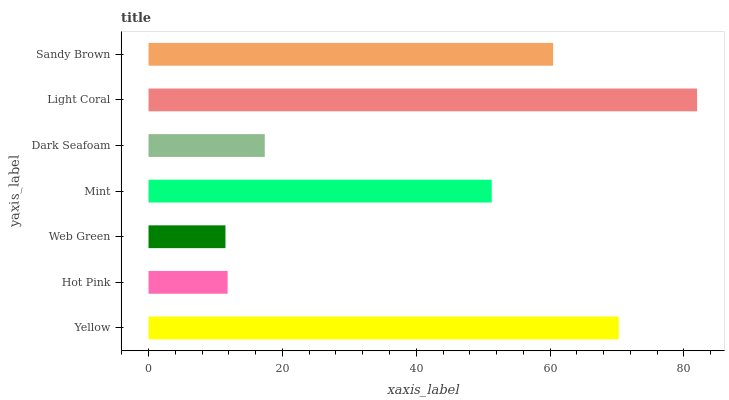Is Web Green the minimum?
Answer yes or no. Yes. Is Light Coral the maximum?
Answer yes or no. Yes. Is Hot Pink the minimum?
Answer yes or no. No. Is Hot Pink the maximum?
Answer yes or no. No. Is Yellow greater than Hot Pink?
Answer yes or no. Yes. Is Hot Pink less than Yellow?
Answer yes or no. Yes. Is Hot Pink greater than Yellow?
Answer yes or no. No. Is Yellow less than Hot Pink?
Answer yes or no. No. Is Mint the high median?
Answer yes or no. Yes. Is Mint the low median?
Answer yes or no. Yes. Is Web Green the high median?
Answer yes or no. No. Is Web Green the low median?
Answer yes or no. No. 